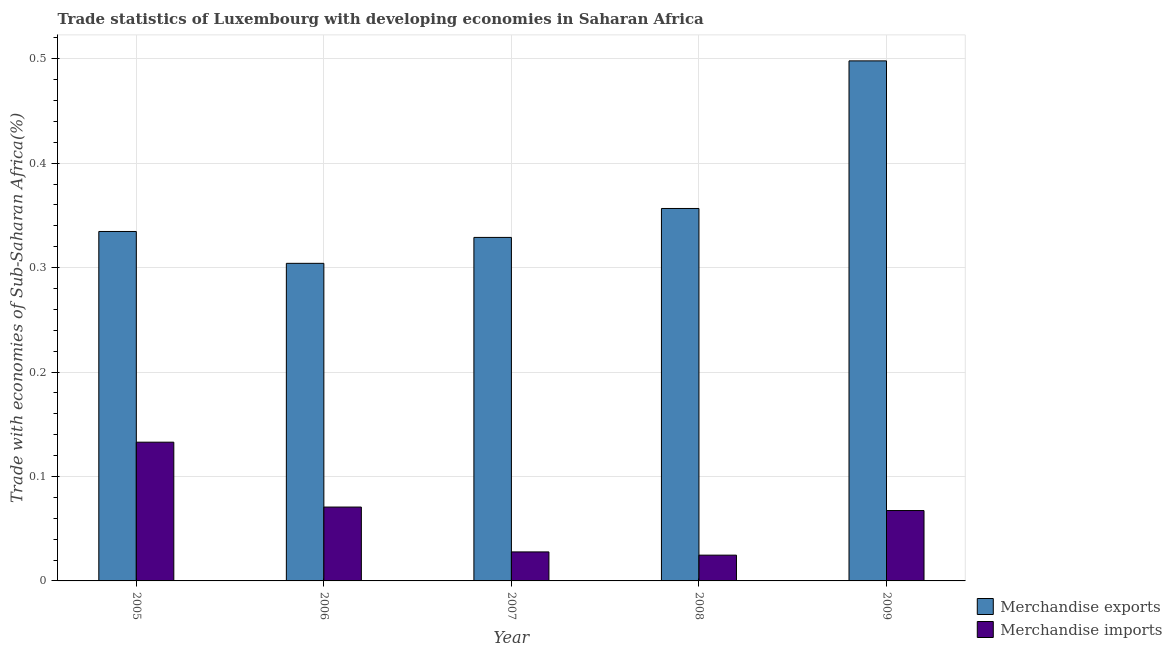How many bars are there on the 3rd tick from the right?
Keep it short and to the point. 2. What is the merchandise imports in 2009?
Provide a short and direct response. 0.07. Across all years, what is the maximum merchandise imports?
Your answer should be very brief. 0.13. Across all years, what is the minimum merchandise exports?
Offer a terse response. 0.3. What is the total merchandise imports in the graph?
Keep it short and to the point. 0.32. What is the difference between the merchandise exports in 2007 and that in 2009?
Provide a short and direct response. -0.17. What is the difference between the merchandise exports in 2006 and the merchandise imports in 2009?
Provide a succinct answer. -0.19. What is the average merchandise exports per year?
Offer a very short reply. 0.36. What is the ratio of the merchandise imports in 2005 to that in 2008?
Provide a succinct answer. 5.38. What is the difference between the highest and the second highest merchandise exports?
Ensure brevity in your answer.  0.14. What is the difference between the highest and the lowest merchandise imports?
Give a very brief answer. 0.11. In how many years, is the merchandise imports greater than the average merchandise imports taken over all years?
Offer a very short reply. 3. Is the sum of the merchandise exports in 2005 and 2008 greater than the maximum merchandise imports across all years?
Make the answer very short. Yes. What does the 1st bar from the left in 2006 represents?
Give a very brief answer. Merchandise exports. How many bars are there?
Offer a very short reply. 10. Are all the bars in the graph horizontal?
Give a very brief answer. No. Are the values on the major ticks of Y-axis written in scientific E-notation?
Ensure brevity in your answer.  No. Where does the legend appear in the graph?
Your answer should be very brief. Bottom right. How are the legend labels stacked?
Your answer should be compact. Vertical. What is the title of the graph?
Offer a very short reply. Trade statistics of Luxembourg with developing economies in Saharan Africa. What is the label or title of the Y-axis?
Ensure brevity in your answer.  Trade with economies of Sub-Saharan Africa(%). What is the Trade with economies of Sub-Saharan Africa(%) of Merchandise exports in 2005?
Keep it short and to the point. 0.33. What is the Trade with economies of Sub-Saharan Africa(%) of Merchandise imports in 2005?
Keep it short and to the point. 0.13. What is the Trade with economies of Sub-Saharan Africa(%) of Merchandise exports in 2006?
Offer a very short reply. 0.3. What is the Trade with economies of Sub-Saharan Africa(%) of Merchandise imports in 2006?
Offer a very short reply. 0.07. What is the Trade with economies of Sub-Saharan Africa(%) of Merchandise exports in 2007?
Your answer should be very brief. 0.33. What is the Trade with economies of Sub-Saharan Africa(%) of Merchandise imports in 2007?
Give a very brief answer. 0.03. What is the Trade with economies of Sub-Saharan Africa(%) in Merchandise exports in 2008?
Offer a terse response. 0.36. What is the Trade with economies of Sub-Saharan Africa(%) in Merchandise imports in 2008?
Provide a succinct answer. 0.02. What is the Trade with economies of Sub-Saharan Africa(%) in Merchandise exports in 2009?
Offer a terse response. 0.5. What is the Trade with economies of Sub-Saharan Africa(%) in Merchandise imports in 2009?
Provide a short and direct response. 0.07. Across all years, what is the maximum Trade with economies of Sub-Saharan Africa(%) in Merchandise exports?
Make the answer very short. 0.5. Across all years, what is the maximum Trade with economies of Sub-Saharan Africa(%) in Merchandise imports?
Keep it short and to the point. 0.13. Across all years, what is the minimum Trade with economies of Sub-Saharan Africa(%) in Merchandise exports?
Your response must be concise. 0.3. Across all years, what is the minimum Trade with economies of Sub-Saharan Africa(%) of Merchandise imports?
Provide a succinct answer. 0.02. What is the total Trade with economies of Sub-Saharan Africa(%) in Merchandise exports in the graph?
Your response must be concise. 1.82. What is the total Trade with economies of Sub-Saharan Africa(%) of Merchandise imports in the graph?
Give a very brief answer. 0.32. What is the difference between the Trade with economies of Sub-Saharan Africa(%) in Merchandise exports in 2005 and that in 2006?
Ensure brevity in your answer.  0.03. What is the difference between the Trade with economies of Sub-Saharan Africa(%) of Merchandise imports in 2005 and that in 2006?
Your answer should be compact. 0.06. What is the difference between the Trade with economies of Sub-Saharan Africa(%) in Merchandise exports in 2005 and that in 2007?
Provide a succinct answer. 0.01. What is the difference between the Trade with economies of Sub-Saharan Africa(%) in Merchandise imports in 2005 and that in 2007?
Your answer should be very brief. 0.11. What is the difference between the Trade with economies of Sub-Saharan Africa(%) in Merchandise exports in 2005 and that in 2008?
Your response must be concise. -0.02. What is the difference between the Trade with economies of Sub-Saharan Africa(%) in Merchandise imports in 2005 and that in 2008?
Your response must be concise. 0.11. What is the difference between the Trade with economies of Sub-Saharan Africa(%) of Merchandise exports in 2005 and that in 2009?
Give a very brief answer. -0.16. What is the difference between the Trade with economies of Sub-Saharan Africa(%) of Merchandise imports in 2005 and that in 2009?
Your response must be concise. 0.07. What is the difference between the Trade with economies of Sub-Saharan Africa(%) of Merchandise exports in 2006 and that in 2007?
Your answer should be very brief. -0.02. What is the difference between the Trade with economies of Sub-Saharan Africa(%) in Merchandise imports in 2006 and that in 2007?
Give a very brief answer. 0.04. What is the difference between the Trade with economies of Sub-Saharan Africa(%) in Merchandise exports in 2006 and that in 2008?
Give a very brief answer. -0.05. What is the difference between the Trade with economies of Sub-Saharan Africa(%) of Merchandise imports in 2006 and that in 2008?
Your response must be concise. 0.05. What is the difference between the Trade with economies of Sub-Saharan Africa(%) in Merchandise exports in 2006 and that in 2009?
Make the answer very short. -0.19. What is the difference between the Trade with economies of Sub-Saharan Africa(%) in Merchandise imports in 2006 and that in 2009?
Make the answer very short. 0. What is the difference between the Trade with economies of Sub-Saharan Africa(%) of Merchandise exports in 2007 and that in 2008?
Give a very brief answer. -0.03. What is the difference between the Trade with economies of Sub-Saharan Africa(%) in Merchandise imports in 2007 and that in 2008?
Offer a terse response. 0. What is the difference between the Trade with economies of Sub-Saharan Africa(%) in Merchandise exports in 2007 and that in 2009?
Give a very brief answer. -0.17. What is the difference between the Trade with economies of Sub-Saharan Africa(%) of Merchandise imports in 2007 and that in 2009?
Keep it short and to the point. -0.04. What is the difference between the Trade with economies of Sub-Saharan Africa(%) in Merchandise exports in 2008 and that in 2009?
Provide a succinct answer. -0.14. What is the difference between the Trade with economies of Sub-Saharan Africa(%) in Merchandise imports in 2008 and that in 2009?
Offer a very short reply. -0.04. What is the difference between the Trade with economies of Sub-Saharan Africa(%) of Merchandise exports in 2005 and the Trade with economies of Sub-Saharan Africa(%) of Merchandise imports in 2006?
Your answer should be very brief. 0.26. What is the difference between the Trade with economies of Sub-Saharan Africa(%) of Merchandise exports in 2005 and the Trade with economies of Sub-Saharan Africa(%) of Merchandise imports in 2007?
Your answer should be compact. 0.31. What is the difference between the Trade with economies of Sub-Saharan Africa(%) in Merchandise exports in 2005 and the Trade with economies of Sub-Saharan Africa(%) in Merchandise imports in 2008?
Make the answer very short. 0.31. What is the difference between the Trade with economies of Sub-Saharan Africa(%) of Merchandise exports in 2005 and the Trade with economies of Sub-Saharan Africa(%) of Merchandise imports in 2009?
Provide a short and direct response. 0.27. What is the difference between the Trade with economies of Sub-Saharan Africa(%) of Merchandise exports in 2006 and the Trade with economies of Sub-Saharan Africa(%) of Merchandise imports in 2007?
Give a very brief answer. 0.28. What is the difference between the Trade with economies of Sub-Saharan Africa(%) of Merchandise exports in 2006 and the Trade with economies of Sub-Saharan Africa(%) of Merchandise imports in 2008?
Your answer should be compact. 0.28. What is the difference between the Trade with economies of Sub-Saharan Africa(%) of Merchandise exports in 2006 and the Trade with economies of Sub-Saharan Africa(%) of Merchandise imports in 2009?
Offer a terse response. 0.24. What is the difference between the Trade with economies of Sub-Saharan Africa(%) of Merchandise exports in 2007 and the Trade with economies of Sub-Saharan Africa(%) of Merchandise imports in 2008?
Ensure brevity in your answer.  0.3. What is the difference between the Trade with economies of Sub-Saharan Africa(%) in Merchandise exports in 2007 and the Trade with economies of Sub-Saharan Africa(%) in Merchandise imports in 2009?
Give a very brief answer. 0.26. What is the difference between the Trade with economies of Sub-Saharan Africa(%) in Merchandise exports in 2008 and the Trade with economies of Sub-Saharan Africa(%) in Merchandise imports in 2009?
Provide a short and direct response. 0.29. What is the average Trade with economies of Sub-Saharan Africa(%) of Merchandise exports per year?
Your answer should be very brief. 0.36. What is the average Trade with economies of Sub-Saharan Africa(%) of Merchandise imports per year?
Provide a short and direct response. 0.06. In the year 2005, what is the difference between the Trade with economies of Sub-Saharan Africa(%) in Merchandise exports and Trade with economies of Sub-Saharan Africa(%) in Merchandise imports?
Provide a succinct answer. 0.2. In the year 2006, what is the difference between the Trade with economies of Sub-Saharan Africa(%) of Merchandise exports and Trade with economies of Sub-Saharan Africa(%) of Merchandise imports?
Ensure brevity in your answer.  0.23. In the year 2007, what is the difference between the Trade with economies of Sub-Saharan Africa(%) of Merchandise exports and Trade with economies of Sub-Saharan Africa(%) of Merchandise imports?
Give a very brief answer. 0.3. In the year 2008, what is the difference between the Trade with economies of Sub-Saharan Africa(%) in Merchandise exports and Trade with economies of Sub-Saharan Africa(%) in Merchandise imports?
Make the answer very short. 0.33. In the year 2009, what is the difference between the Trade with economies of Sub-Saharan Africa(%) in Merchandise exports and Trade with economies of Sub-Saharan Africa(%) in Merchandise imports?
Make the answer very short. 0.43. What is the ratio of the Trade with economies of Sub-Saharan Africa(%) in Merchandise exports in 2005 to that in 2006?
Your response must be concise. 1.1. What is the ratio of the Trade with economies of Sub-Saharan Africa(%) of Merchandise imports in 2005 to that in 2006?
Keep it short and to the point. 1.88. What is the ratio of the Trade with economies of Sub-Saharan Africa(%) of Merchandise exports in 2005 to that in 2007?
Provide a succinct answer. 1.02. What is the ratio of the Trade with economies of Sub-Saharan Africa(%) in Merchandise imports in 2005 to that in 2007?
Make the answer very short. 4.78. What is the ratio of the Trade with economies of Sub-Saharan Africa(%) of Merchandise exports in 2005 to that in 2008?
Offer a very short reply. 0.94. What is the ratio of the Trade with economies of Sub-Saharan Africa(%) in Merchandise imports in 2005 to that in 2008?
Ensure brevity in your answer.  5.38. What is the ratio of the Trade with economies of Sub-Saharan Africa(%) in Merchandise exports in 2005 to that in 2009?
Offer a terse response. 0.67. What is the ratio of the Trade with economies of Sub-Saharan Africa(%) in Merchandise imports in 2005 to that in 2009?
Your answer should be very brief. 1.97. What is the ratio of the Trade with economies of Sub-Saharan Africa(%) in Merchandise exports in 2006 to that in 2007?
Keep it short and to the point. 0.92. What is the ratio of the Trade with economies of Sub-Saharan Africa(%) of Merchandise imports in 2006 to that in 2007?
Keep it short and to the point. 2.55. What is the ratio of the Trade with economies of Sub-Saharan Africa(%) in Merchandise exports in 2006 to that in 2008?
Ensure brevity in your answer.  0.85. What is the ratio of the Trade with economies of Sub-Saharan Africa(%) of Merchandise imports in 2006 to that in 2008?
Make the answer very short. 2.87. What is the ratio of the Trade with economies of Sub-Saharan Africa(%) in Merchandise exports in 2006 to that in 2009?
Your answer should be very brief. 0.61. What is the ratio of the Trade with economies of Sub-Saharan Africa(%) in Merchandise imports in 2006 to that in 2009?
Provide a short and direct response. 1.05. What is the ratio of the Trade with economies of Sub-Saharan Africa(%) in Merchandise exports in 2007 to that in 2008?
Provide a short and direct response. 0.92. What is the ratio of the Trade with economies of Sub-Saharan Africa(%) of Merchandise imports in 2007 to that in 2008?
Make the answer very short. 1.13. What is the ratio of the Trade with economies of Sub-Saharan Africa(%) in Merchandise exports in 2007 to that in 2009?
Keep it short and to the point. 0.66. What is the ratio of the Trade with economies of Sub-Saharan Africa(%) in Merchandise imports in 2007 to that in 2009?
Give a very brief answer. 0.41. What is the ratio of the Trade with economies of Sub-Saharan Africa(%) in Merchandise exports in 2008 to that in 2009?
Ensure brevity in your answer.  0.72. What is the ratio of the Trade with economies of Sub-Saharan Africa(%) in Merchandise imports in 2008 to that in 2009?
Give a very brief answer. 0.37. What is the difference between the highest and the second highest Trade with economies of Sub-Saharan Africa(%) in Merchandise exports?
Ensure brevity in your answer.  0.14. What is the difference between the highest and the second highest Trade with economies of Sub-Saharan Africa(%) of Merchandise imports?
Your answer should be compact. 0.06. What is the difference between the highest and the lowest Trade with economies of Sub-Saharan Africa(%) of Merchandise exports?
Make the answer very short. 0.19. What is the difference between the highest and the lowest Trade with economies of Sub-Saharan Africa(%) in Merchandise imports?
Ensure brevity in your answer.  0.11. 